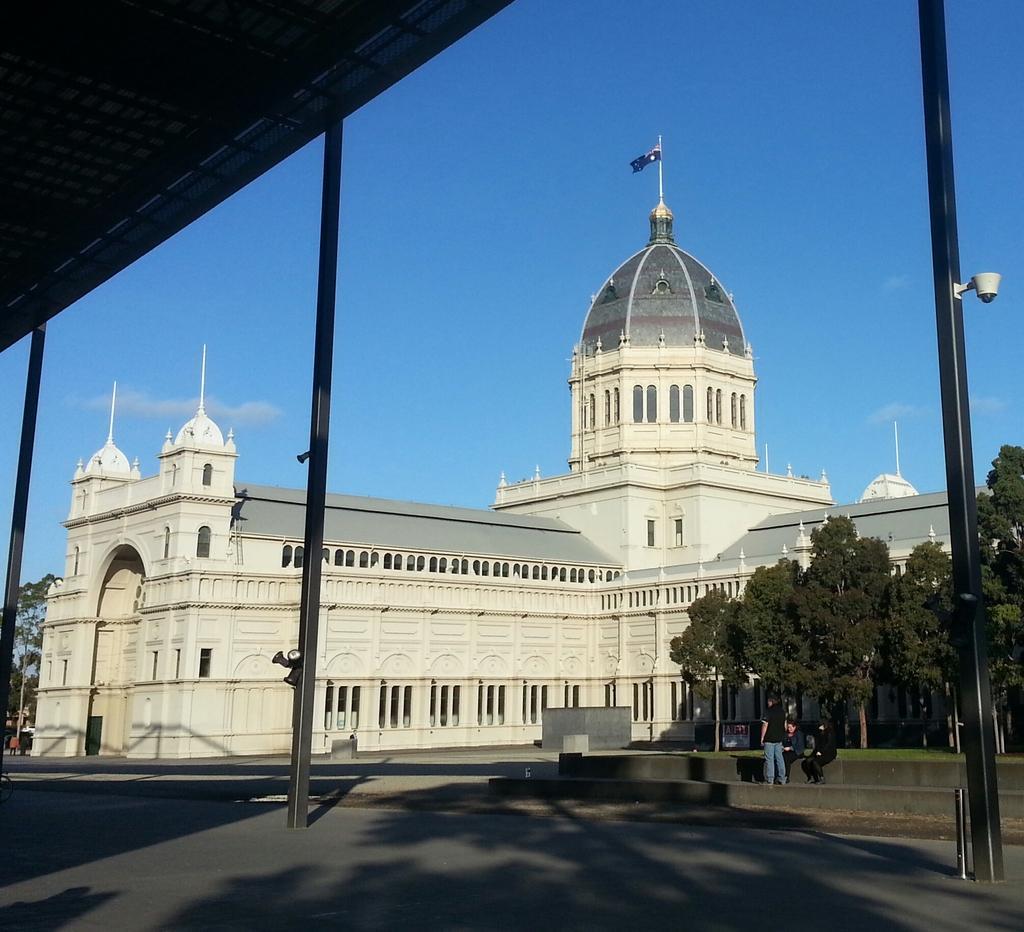In one or two sentences, can you explain what this image depicts? Building with windows. Here we can see flag, trees and people. Sky is in blue color. 